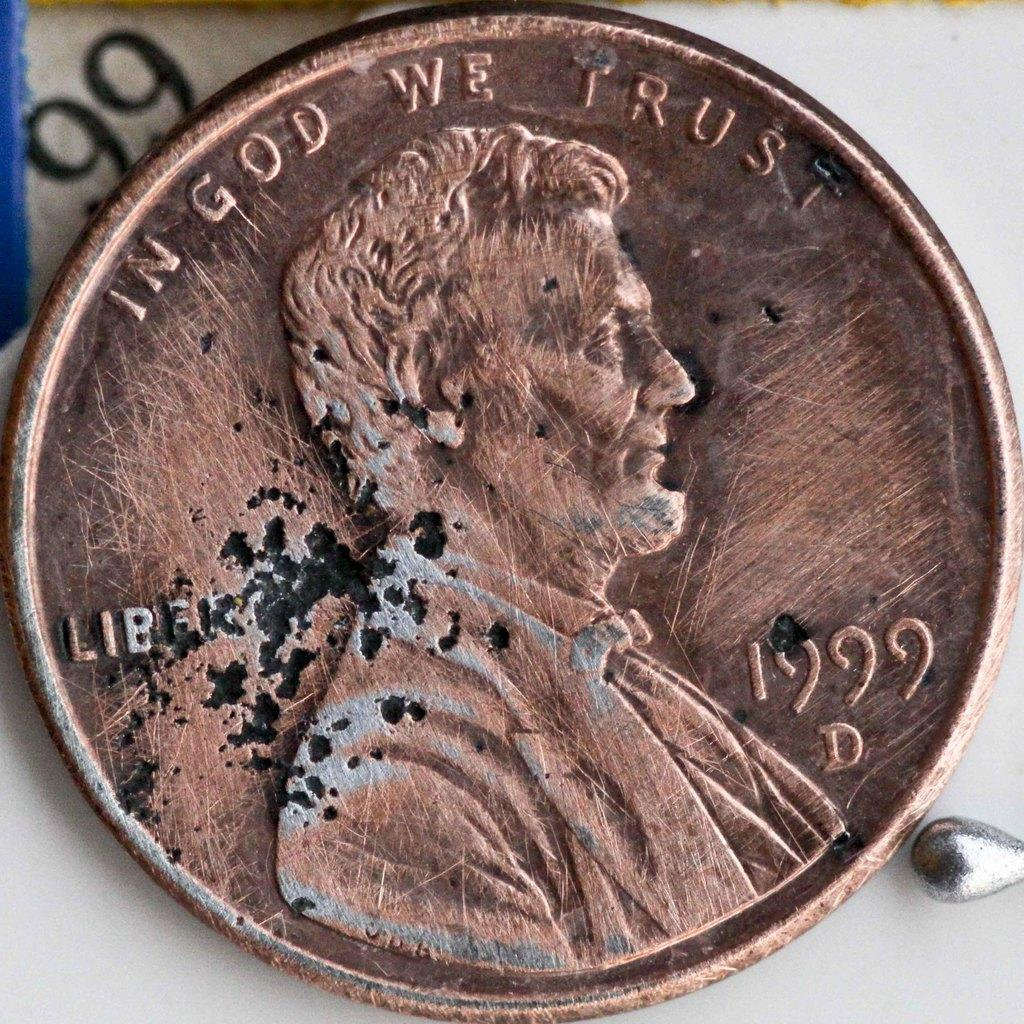<image>
Describe the image concisely. A penny from 1999 says "In God We Trust" at the top. 